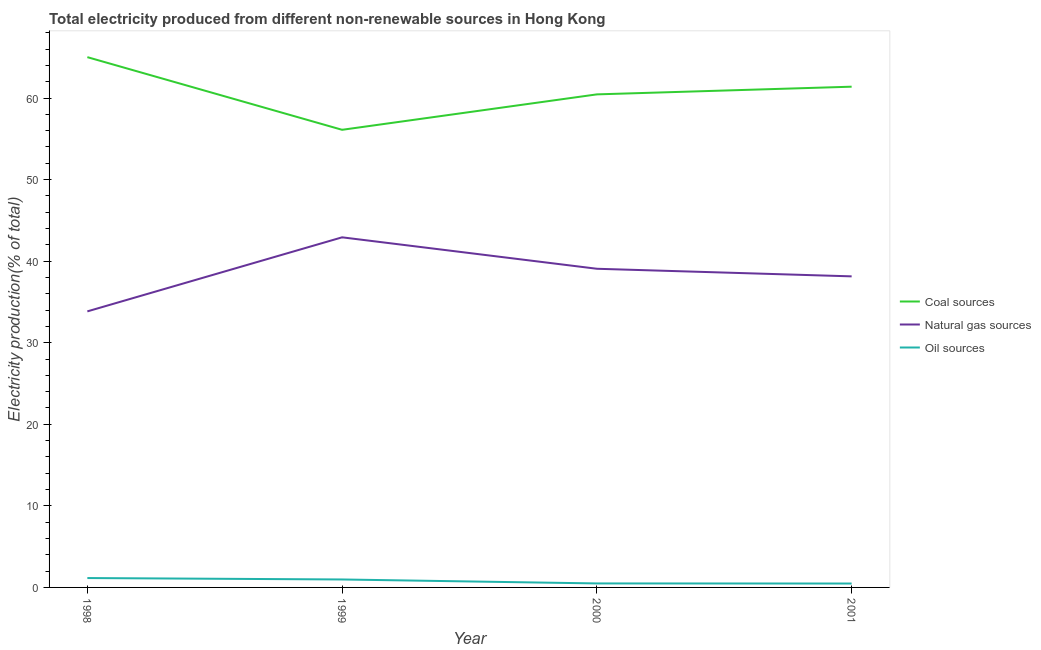Is the number of lines equal to the number of legend labels?
Ensure brevity in your answer.  Yes. What is the percentage of electricity produced by coal in 2000?
Give a very brief answer. 60.44. Across all years, what is the maximum percentage of electricity produced by natural gas?
Offer a very short reply. 42.92. Across all years, what is the minimum percentage of electricity produced by oil sources?
Provide a succinct answer. 0.48. What is the total percentage of electricity produced by oil sources in the graph?
Make the answer very short. 3.09. What is the difference between the percentage of electricity produced by oil sources in 1999 and that in 2001?
Provide a succinct answer. 0.5. What is the difference between the percentage of electricity produced by coal in 1999 and the percentage of electricity produced by oil sources in 2000?
Provide a succinct answer. 55.61. What is the average percentage of electricity produced by coal per year?
Provide a short and direct response. 60.74. In the year 1999, what is the difference between the percentage of electricity produced by oil sources and percentage of electricity produced by coal?
Make the answer very short. -55.13. In how many years, is the percentage of electricity produced by coal greater than 16 %?
Give a very brief answer. 4. What is the ratio of the percentage of electricity produced by coal in 1999 to that in 2001?
Provide a succinct answer. 0.91. Is the difference between the percentage of electricity produced by coal in 1999 and 2001 greater than the difference between the percentage of electricity produced by oil sources in 1999 and 2001?
Your response must be concise. No. What is the difference between the highest and the second highest percentage of electricity produced by coal?
Provide a succinct answer. 3.62. What is the difference between the highest and the lowest percentage of electricity produced by oil sources?
Your answer should be very brief. 0.67. In how many years, is the percentage of electricity produced by natural gas greater than the average percentage of electricity produced by natural gas taken over all years?
Ensure brevity in your answer.  2. Is the sum of the percentage of electricity produced by natural gas in 1999 and 2001 greater than the maximum percentage of electricity produced by oil sources across all years?
Make the answer very short. Yes. Is it the case that in every year, the sum of the percentage of electricity produced by coal and percentage of electricity produced by natural gas is greater than the percentage of electricity produced by oil sources?
Your response must be concise. Yes. Does the percentage of electricity produced by natural gas monotonically increase over the years?
Your answer should be compact. No. How many years are there in the graph?
Make the answer very short. 4. What is the difference between two consecutive major ticks on the Y-axis?
Keep it short and to the point. 10. Does the graph contain any zero values?
Your answer should be compact. No. How many legend labels are there?
Your answer should be very brief. 3. What is the title of the graph?
Your answer should be compact. Total electricity produced from different non-renewable sources in Hong Kong. What is the label or title of the X-axis?
Keep it short and to the point. Year. What is the Electricity production(% of total) in Coal sources in 1998?
Keep it short and to the point. 65.01. What is the Electricity production(% of total) in Natural gas sources in 1998?
Offer a very short reply. 33.84. What is the Electricity production(% of total) of Oil sources in 1998?
Offer a terse response. 1.15. What is the Electricity production(% of total) of Coal sources in 1999?
Your response must be concise. 56.1. What is the Electricity production(% of total) of Natural gas sources in 1999?
Provide a succinct answer. 42.92. What is the Electricity production(% of total) of Oil sources in 1999?
Your answer should be very brief. 0.98. What is the Electricity production(% of total) in Coal sources in 2000?
Give a very brief answer. 60.44. What is the Electricity production(% of total) of Natural gas sources in 2000?
Ensure brevity in your answer.  39.07. What is the Electricity production(% of total) of Oil sources in 2000?
Give a very brief answer. 0.49. What is the Electricity production(% of total) of Coal sources in 2001?
Offer a terse response. 61.39. What is the Electricity production(% of total) of Natural gas sources in 2001?
Ensure brevity in your answer.  38.14. What is the Electricity production(% of total) of Oil sources in 2001?
Provide a short and direct response. 0.48. Across all years, what is the maximum Electricity production(% of total) of Coal sources?
Provide a succinct answer. 65.01. Across all years, what is the maximum Electricity production(% of total) of Natural gas sources?
Make the answer very short. 42.92. Across all years, what is the maximum Electricity production(% of total) in Oil sources?
Ensure brevity in your answer.  1.15. Across all years, what is the minimum Electricity production(% of total) in Coal sources?
Keep it short and to the point. 56.1. Across all years, what is the minimum Electricity production(% of total) in Natural gas sources?
Make the answer very short. 33.84. Across all years, what is the minimum Electricity production(% of total) of Oil sources?
Provide a succinct answer. 0.48. What is the total Electricity production(% of total) of Coal sources in the graph?
Provide a succinct answer. 242.94. What is the total Electricity production(% of total) of Natural gas sources in the graph?
Ensure brevity in your answer.  153.97. What is the total Electricity production(% of total) in Oil sources in the graph?
Make the answer very short. 3.09. What is the difference between the Electricity production(% of total) in Coal sources in 1998 and that in 1999?
Make the answer very short. 8.91. What is the difference between the Electricity production(% of total) of Natural gas sources in 1998 and that in 1999?
Your response must be concise. -9.08. What is the difference between the Electricity production(% of total) in Oil sources in 1998 and that in 1999?
Keep it short and to the point. 0.17. What is the difference between the Electricity production(% of total) of Coal sources in 1998 and that in 2000?
Provide a succinct answer. 4.56. What is the difference between the Electricity production(% of total) in Natural gas sources in 1998 and that in 2000?
Your answer should be very brief. -5.23. What is the difference between the Electricity production(% of total) in Oil sources in 1998 and that in 2000?
Provide a succinct answer. 0.66. What is the difference between the Electricity production(% of total) of Coal sources in 1998 and that in 2001?
Your answer should be very brief. 3.62. What is the difference between the Electricity production(% of total) in Natural gas sources in 1998 and that in 2001?
Keep it short and to the point. -4.29. What is the difference between the Electricity production(% of total) of Oil sources in 1998 and that in 2001?
Your answer should be compact. 0.67. What is the difference between the Electricity production(% of total) of Coal sources in 1999 and that in 2000?
Ensure brevity in your answer.  -4.34. What is the difference between the Electricity production(% of total) in Natural gas sources in 1999 and that in 2000?
Your response must be concise. 3.85. What is the difference between the Electricity production(% of total) of Oil sources in 1999 and that in 2000?
Your answer should be compact. 0.49. What is the difference between the Electricity production(% of total) of Coal sources in 1999 and that in 2001?
Give a very brief answer. -5.28. What is the difference between the Electricity production(% of total) in Natural gas sources in 1999 and that in 2001?
Give a very brief answer. 4.79. What is the difference between the Electricity production(% of total) of Oil sources in 1999 and that in 2001?
Ensure brevity in your answer.  0.5. What is the difference between the Electricity production(% of total) of Coal sources in 2000 and that in 2001?
Provide a succinct answer. -0.94. What is the difference between the Electricity production(% of total) of Natural gas sources in 2000 and that in 2001?
Your response must be concise. 0.93. What is the difference between the Electricity production(% of total) in Oil sources in 2000 and that in 2001?
Provide a short and direct response. 0.01. What is the difference between the Electricity production(% of total) in Coal sources in 1998 and the Electricity production(% of total) in Natural gas sources in 1999?
Give a very brief answer. 22.09. What is the difference between the Electricity production(% of total) in Coal sources in 1998 and the Electricity production(% of total) in Oil sources in 1999?
Provide a succinct answer. 64.03. What is the difference between the Electricity production(% of total) of Natural gas sources in 1998 and the Electricity production(% of total) of Oil sources in 1999?
Offer a terse response. 32.87. What is the difference between the Electricity production(% of total) in Coal sources in 1998 and the Electricity production(% of total) in Natural gas sources in 2000?
Give a very brief answer. 25.94. What is the difference between the Electricity production(% of total) in Coal sources in 1998 and the Electricity production(% of total) in Oil sources in 2000?
Your answer should be compact. 64.52. What is the difference between the Electricity production(% of total) of Natural gas sources in 1998 and the Electricity production(% of total) of Oil sources in 2000?
Offer a terse response. 33.35. What is the difference between the Electricity production(% of total) of Coal sources in 1998 and the Electricity production(% of total) of Natural gas sources in 2001?
Make the answer very short. 26.87. What is the difference between the Electricity production(% of total) of Coal sources in 1998 and the Electricity production(% of total) of Oil sources in 2001?
Offer a very short reply. 64.53. What is the difference between the Electricity production(% of total) of Natural gas sources in 1998 and the Electricity production(% of total) of Oil sources in 2001?
Your answer should be compact. 33.36. What is the difference between the Electricity production(% of total) of Coal sources in 1999 and the Electricity production(% of total) of Natural gas sources in 2000?
Your answer should be compact. 17.04. What is the difference between the Electricity production(% of total) in Coal sources in 1999 and the Electricity production(% of total) in Oil sources in 2000?
Provide a succinct answer. 55.61. What is the difference between the Electricity production(% of total) of Natural gas sources in 1999 and the Electricity production(% of total) of Oil sources in 2000?
Offer a very short reply. 42.43. What is the difference between the Electricity production(% of total) in Coal sources in 1999 and the Electricity production(% of total) in Natural gas sources in 2001?
Offer a very short reply. 17.97. What is the difference between the Electricity production(% of total) in Coal sources in 1999 and the Electricity production(% of total) in Oil sources in 2001?
Make the answer very short. 55.62. What is the difference between the Electricity production(% of total) in Natural gas sources in 1999 and the Electricity production(% of total) in Oil sources in 2001?
Make the answer very short. 42.44. What is the difference between the Electricity production(% of total) of Coal sources in 2000 and the Electricity production(% of total) of Natural gas sources in 2001?
Provide a succinct answer. 22.31. What is the difference between the Electricity production(% of total) in Coal sources in 2000 and the Electricity production(% of total) in Oil sources in 2001?
Offer a terse response. 59.97. What is the difference between the Electricity production(% of total) of Natural gas sources in 2000 and the Electricity production(% of total) of Oil sources in 2001?
Your answer should be compact. 38.59. What is the average Electricity production(% of total) in Coal sources per year?
Keep it short and to the point. 60.74. What is the average Electricity production(% of total) of Natural gas sources per year?
Provide a succinct answer. 38.49. What is the average Electricity production(% of total) in Oil sources per year?
Offer a very short reply. 0.77. In the year 1998, what is the difference between the Electricity production(% of total) in Coal sources and Electricity production(% of total) in Natural gas sources?
Provide a short and direct response. 31.17. In the year 1998, what is the difference between the Electricity production(% of total) in Coal sources and Electricity production(% of total) in Oil sources?
Your response must be concise. 63.86. In the year 1998, what is the difference between the Electricity production(% of total) of Natural gas sources and Electricity production(% of total) of Oil sources?
Provide a short and direct response. 32.69. In the year 1999, what is the difference between the Electricity production(% of total) of Coal sources and Electricity production(% of total) of Natural gas sources?
Provide a succinct answer. 13.18. In the year 1999, what is the difference between the Electricity production(% of total) of Coal sources and Electricity production(% of total) of Oil sources?
Keep it short and to the point. 55.13. In the year 1999, what is the difference between the Electricity production(% of total) in Natural gas sources and Electricity production(% of total) in Oil sources?
Provide a short and direct response. 41.95. In the year 2000, what is the difference between the Electricity production(% of total) of Coal sources and Electricity production(% of total) of Natural gas sources?
Provide a succinct answer. 21.38. In the year 2000, what is the difference between the Electricity production(% of total) in Coal sources and Electricity production(% of total) in Oil sources?
Provide a short and direct response. 59.96. In the year 2000, what is the difference between the Electricity production(% of total) of Natural gas sources and Electricity production(% of total) of Oil sources?
Keep it short and to the point. 38.58. In the year 2001, what is the difference between the Electricity production(% of total) in Coal sources and Electricity production(% of total) in Natural gas sources?
Provide a succinct answer. 23.25. In the year 2001, what is the difference between the Electricity production(% of total) of Coal sources and Electricity production(% of total) of Oil sources?
Offer a terse response. 60.91. In the year 2001, what is the difference between the Electricity production(% of total) in Natural gas sources and Electricity production(% of total) in Oil sources?
Offer a terse response. 37.66. What is the ratio of the Electricity production(% of total) in Coal sources in 1998 to that in 1999?
Provide a succinct answer. 1.16. What is the ratio of the Electricity production(% of total) in Natural gas sources in 1998 to that in 1999?
Your response must be concise. 0.79. What is the ratio of the Electricity production(% of total) of Oil sources in 1998 to that in 1999?
Provide a short and direct response. 1.18. What is the ratio of the Electricity production(% of total) in Coal sources in 1998 to that in 2000?
Your response must be concise. 1.08. What is the ratio of the Electricity production(% of total) in Natural gas sources in 1998 to that in 2000?
Your answer should be very brief. 0.87. What is the ratio of the Electricity production(% of total) of Oil sources in 1998 to that in 2000?
Give a very brief answer. 2.35. What is the ratio of the Electricity production(% of total) of Coal sources in 1998 to that in 2001?
Your answer should be compact. 1.06. What is the ratio of the Electricity production(% of total) in Natural gas sources in 1998 to that in 2001?
Your answer should be compact. 0.89. What is the ratio of the Electricity production(% of total) of Oil sources in 1998 to that in 2001?
Your response must be concise. 2.4. What is the ratio of the Electricity production(% of total) in Coal sources in 1999 to that in 2000?
Ensure brevity in your answer.  0.93. What is the ratio of the Electricity production(% of total) in Natural gas sources in 1999 to that in 2000?
Offer a terse response. 1.1. What is the ratio of the Electricity production(% of total) of Oil sources in 1999 to that in 2000?
Offer a very short reply. 2. What is the ratio of the Electricity production(% of total) in Coal sources in 1999 to that in 2001?
Provide a succinct answer. 0.91. What is the ratio of the Electricity production(% of total) in Natural gas sources in 1999 to that in 2001?
Ensure brevity in your answer.  1.13. What is the ratio of the Electricity production(% of total) of Oil sources in 1999 to that in 2001?
Your answer should be compact. 2.04. What is the ratio of the Electricity production(% of total) in Coal sources in 2000 to that in 2001?
Keep it short and to the point. 0.98. What is the ratio of the Electricity production(% of total) of Natural gas sources in 2000 to that in 2001?
Ensure brevity in your answer.  1.02. What is the ratio of the Electricity production(% of total) in Oil sources in 2000 to that in 2001?
Your response must be concise. 1.02. What is the difference between the highest and the second highest Electricity production(% of total) in Coal sources?
Make the answer very short. 3.62. What is the difference between the highest and the second highest Electricity production(% of total) in Natural gas sources?
Keep it short and to the point. 3.85. What is the difference between the highest and the second highest Electricity production(% of total) of Oil sources?
Your answer should be compact. 0.17. What is the difference between the highest and the lowest Electricity production(% of total) of Coal sources?
Provide a succinct answer. 8.91. What is the difference between the highest and the lowest Electricity production(% of total) of Natural gas sources?
Provide a succinct answer. 9.08. What is the difference between the highest and the lowest Electricity production(% of total) of Oil sources?
Offer a terse response. 0.67. 